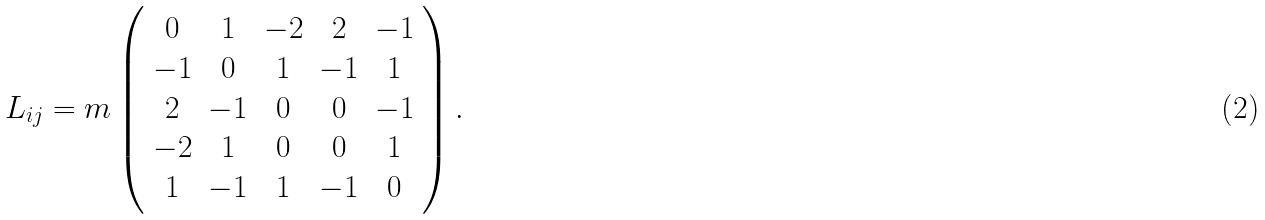<formula> <loc_0><loc_0><loc_500><loc_500>L _ { i j } = m \left ( \begin{array} { c c c c c } 0 & 1 & - 2 & 2 & - 1 \\ - 1 & 0 & 1 & - 1 & 1 \\ 2 & - 1 & 0 & 0 & - 1 \\ - 2 & 1 & 0 & 0 & 1 \\ 1 & - 1 & 1 & - 1 & 0 \end{array} \right ) .</formula> 